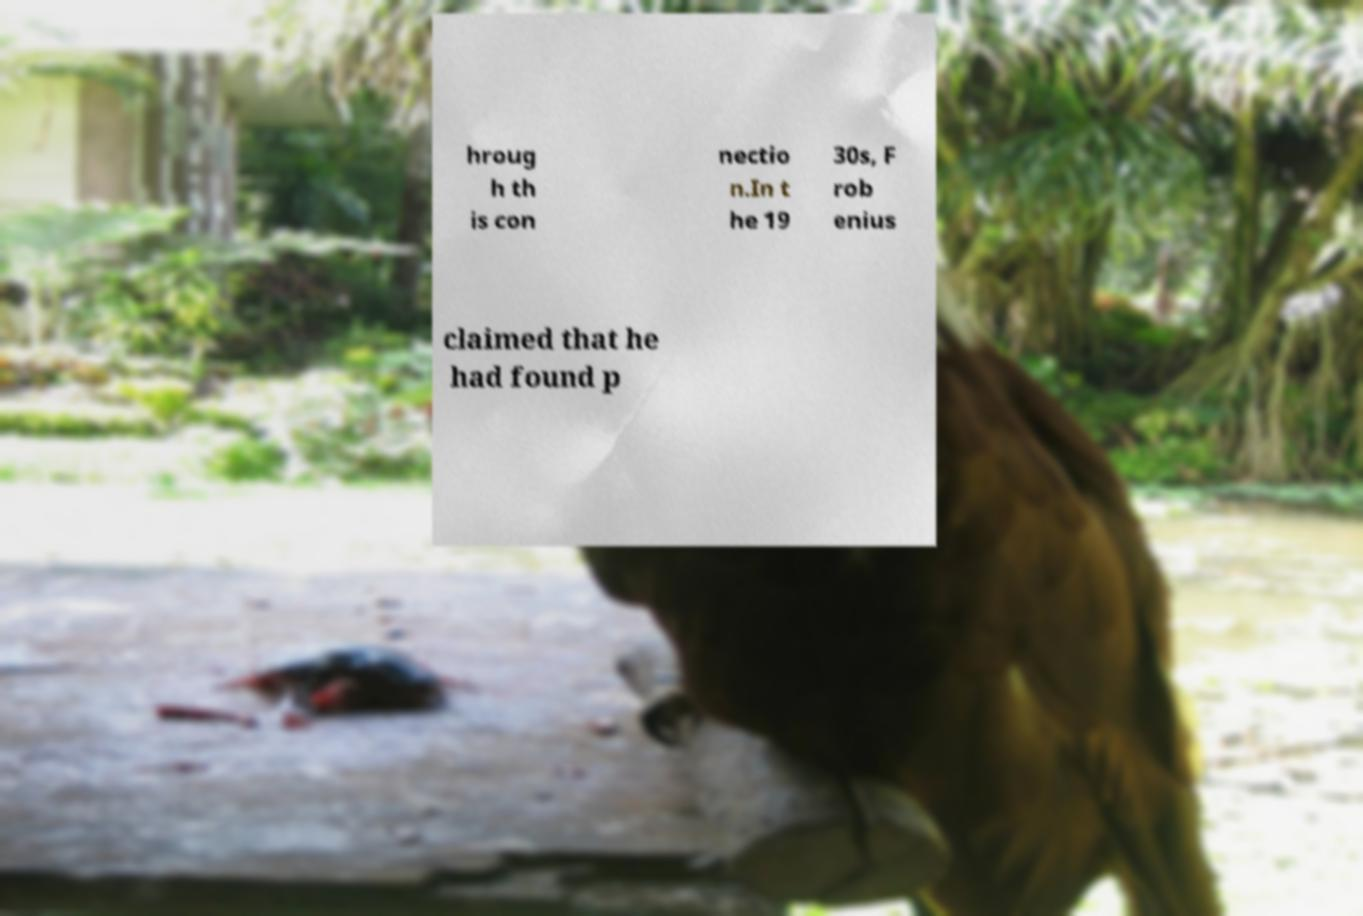I need the written content from this picture converted into text. Can you do that? hroug h th is con nectio n.In t he 19 30s, F rob enius claimed that he had found p 